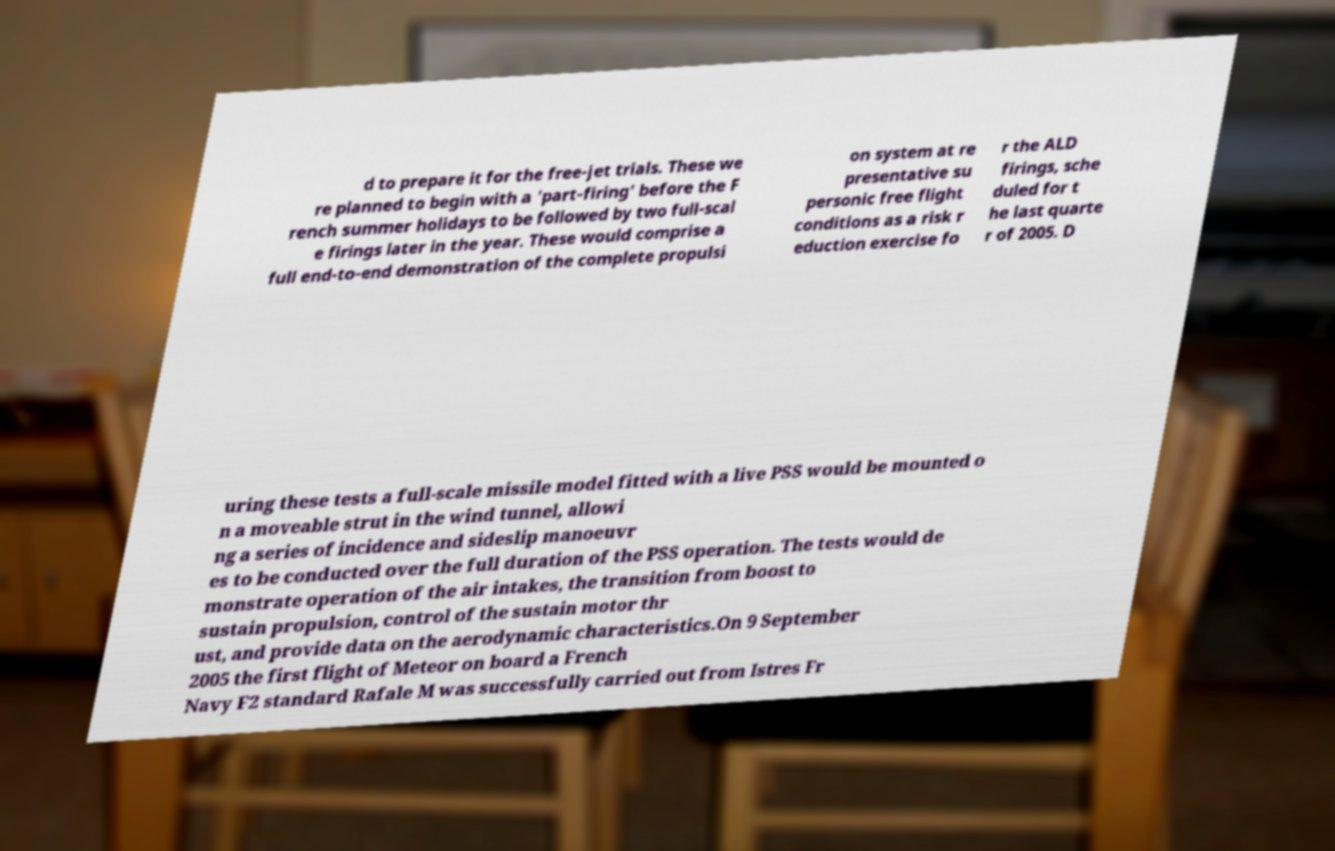There's text embedded in this image that I need extracted. Can you transcribe it verbatim? d to prepare it for the free-jet trials. These we re planned to begin with a 'part-firing' before the F rench summer holidays to be followed by two full-scal e firings later in the year. These would comprise a full end-to-end demonstration of the complete propulsi on system at re presentative su personic free flight conditions as a risk r eduction exercise fo r the ALD firings, sche duled for t he last quarte r of 2005. D uring these tests a full-scale missile model fitted with a live PSS would be mounted o n a moveable strut in the wind tunnel, allowi ng a series of incidence and sideslip manoeuvr es to be conducted over the full duration of the PSS operation. The tests would de monstrate operation of the air intakes, the transition from boost to sustain propulsion, control of the sustain motor thr ust, and provide data on the aerodynamic characteristics.On 9 September 2005 the first flight of Meteor on board a French Navy F2 standard Rafale M was successfully carried out from Istres Fr 